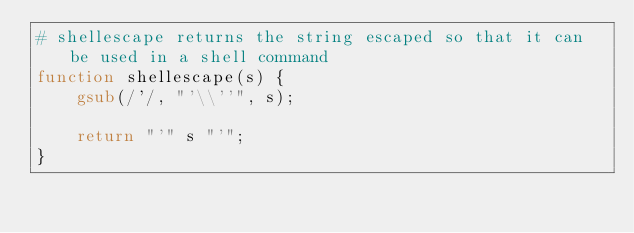<code> <loc_0><loc_0><loc_500><loc_500><_Awk_># shellescape returns the string escaped so that it can be used in a shell command
function shellescape(s) {
    gsub(/'/, "'\\''", s);

    return "'" s "'";
}
</code> 